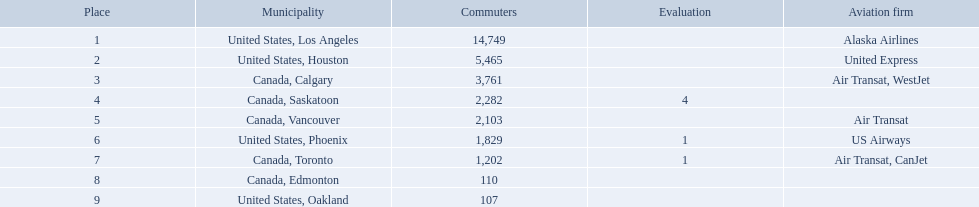What are all the cities? United States, Los Angeles, United States, Houston, Canada, Calgary, Canada, Saskatoon, Canada, Vancouver, United States, Phoenix, Canada, Toronto, Canada, Edmonton, United States, Oakland. How many passengers do they service? 14,749, 5,465, 3,761, 2,282, 2,103, 1,829, 1,202, 110, 107. Which city, when combined with los angeles, totals nearly 19,000? Canada, Calgary. What are the cities that are associated with the playa de oro international airport? United States, Los Angeles, United States, Houston, Canada, Calgary, Canada, Saskatoon, Canada, Vancouver, United States, Phoenix, Canada, Toronto, Canada, Edmonton, United States, Oakland. What is uniteed states, los angeles passenger count? 14,749. What other cities passenger count would lead to 19,000 roughly when combined with previous los angeles? Canada, Calgary. What cities do the planes fly to? United States, Los Angeles, United States, Houston, Canada, Calgary, Canada, Saskatoon, Canada, Vancouver, United States, Phoenix, Canada, Toronto, Canada, Edmonton, United States, Oakland. How many people are flying to phoenix, arizona? 1,829. What are the cities flown to? United States, Los Angeles, United States, Houston, Canada, Calgary, Canada, Saskatoon, Canada, Vancouver, United States, Phoenix, Canada, Toronto, Canada, Edmonton, United States, Oakland. What number of passengers did pheonix have? 1,829. 